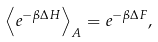Convert formula to latex. <formula><loc_0><loc_0><loc_500><loc_500>\left \langle e ^ { - \beta \Delta H } \right \rangle _ { A } = e ^ { - \beta \Delta F } ,</formula> 